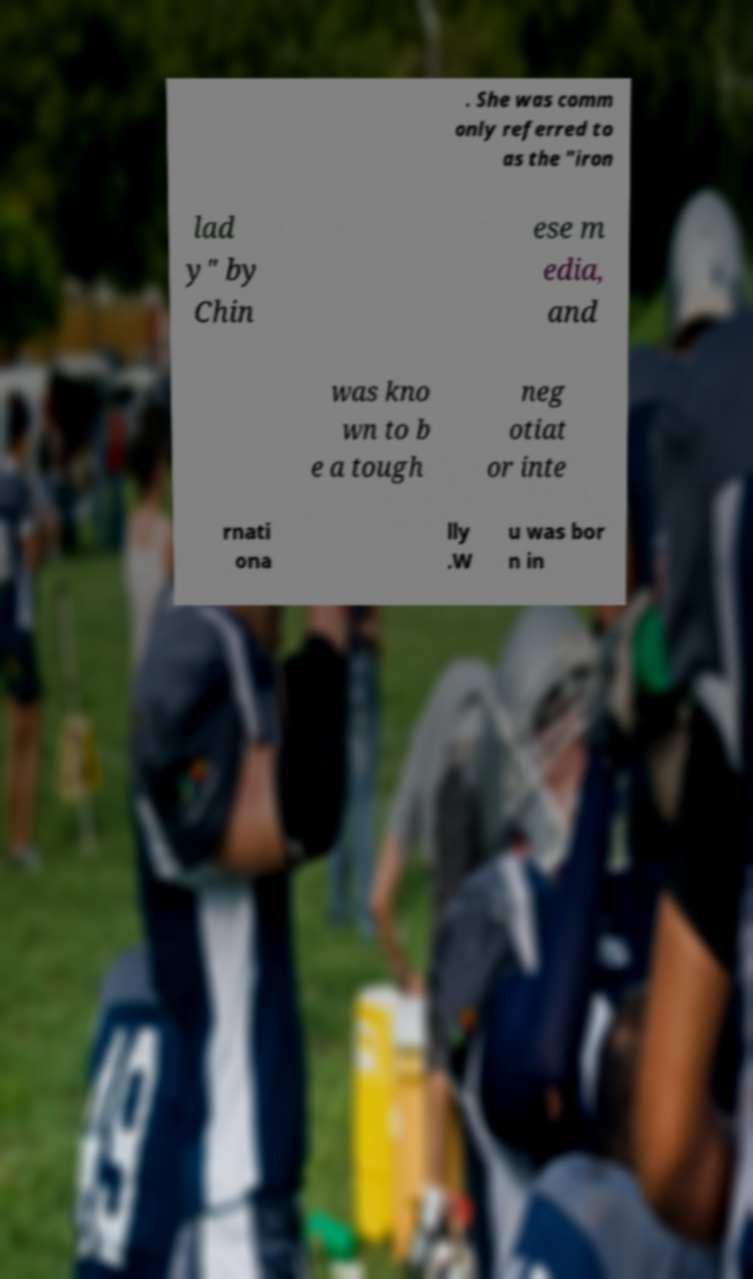Can you read and provide the text displayed in the image?This photo seems to have some interesting text. Can you extract and type it out for me? . She was comm only referred to as the "iron lad y" by Chin ese m edia, and was kno wn to b e a tough neg otiat or inte rnati ona lly .W u was bor n in 